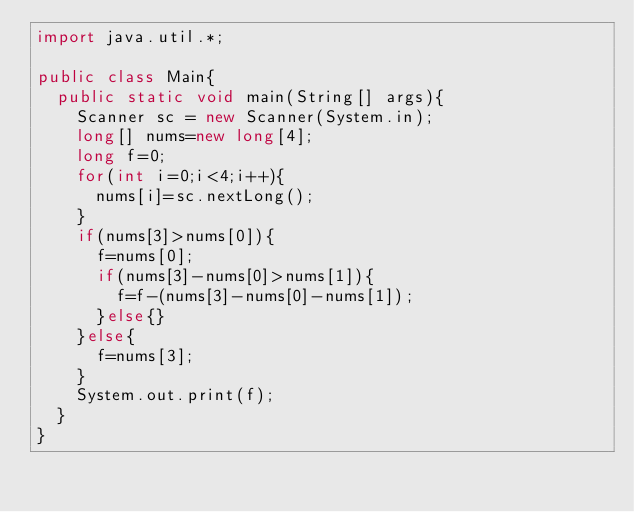Convert code to text. <code><loc_0><loc_0><loc_500><loc_500><_Java_>import java.util.*;

public class Main{
  public static void main(String[] args){
    Scanner sc = new Scanner(System.in);
  	long[] nums=new long[4];
    long f=0;
    for(int i=0;i<4;i++){
      nums[i]=sc.nextLong();
    }
    if(nums[3]>nums[0]){
      f=nums[0];
      if(nums[3]-nums[0]>nums[1]){
        f=f-(nums[3]-nums[0]-nums[1]);
      }else{}
    }else{
      f=nums[3];
    }
    System.out.print(f);
  }
}
</code> 